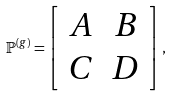Convert formula to latex. <formula><loc_0><loc_0><loc_500><loc_500>\mathbb { P } ^ { ( g ) } = \left [ \begin{array} { c c } A & B \\ C & D \end{array} \right ] ,</formula> 